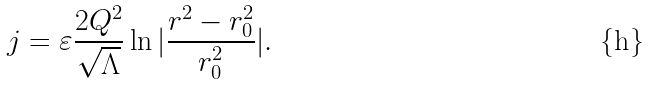Convert formula to latex. <formula><loc_0><loc_0><loc_500><loc_500>j = \varepsilon \frac { 2 Q ^ { 2 } } { \sqrt { \Lambda } } \ln | \frac { r ^ { 2 } - r _ { 0 } ^ { 2 } } { r _ { 0 } ^ { 2 } } | .</formula> 